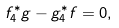<formula> <loc_0><loc_0><loc_500><loc_500>f ^ { * } _ { 4 } g - g ^ { * } _ { 4 } f = 0 ,</formula> 